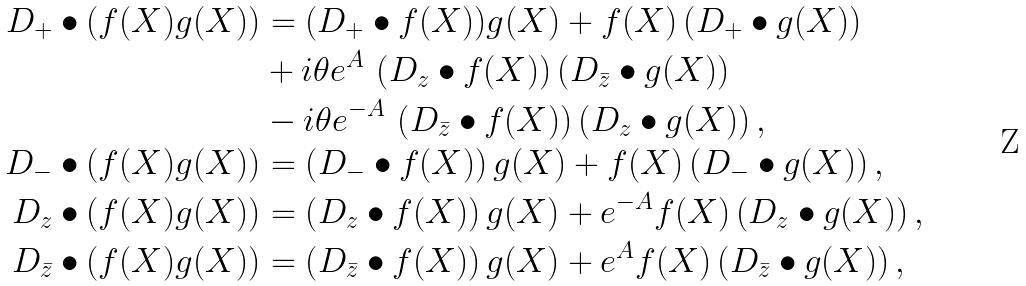Convert formula to latex. <formula><loc_0><loc_0><loc_500><loc_500>D _ { + } \bullet ( f ( X ) g ( X ) ) & = ( D _ { + } \bullet f ( X ) ) g ( X ) + f ( X ) \left ( D _ { + } \bullet g ( X ) \right ) \\ & + i \theta e ^ { A } \, \left ( D _ { z } \bullet f ( X ) \right ) \left ( D _ { \bar { z } } \bullet g ( X ) \right ) \\ & - i \theta e ^ { - A } \, \left ( D _ { \bar { z } } \bullet f ( X ) \right ) \left ( D _ { z } \bullet g ( X ) \right ) , \\ D _ { - } \bullet ( f ( X ) g ( X ) ) & = \left ( D _ { - } \bullet f ( X ) \right ) g ( X ) + f ( X ) \left ( D _ { - } \bullet g ( X ) \right ) , \\ D _ { z } \bullet ( f ( X ) g ( X ) ) & = \left ( D _ { z } \bullet f ( X ) \right ) g ( X ) + e ^ { - A } f ( X ) \left ( D _ { z } \bullet g ( X ) \right ) , \\ D _ { \bar { z } } \bullet ( f ( X ) g ( X ) ) & = \left ( D _ { \bar { z } } \bullet f ( X ) \right ) g ( X ) + e ^ { A } f ( X ) \left ( D _ { \bar { z } } \bullet g ( X ) \right ) ,</formula> 